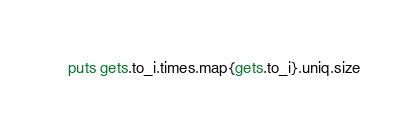<code> <loc_0><loc_0><loc_500><loc_500><_Ruby_>puts gets.to_i.times.map{gets.to_i}.uniq.size</code> 